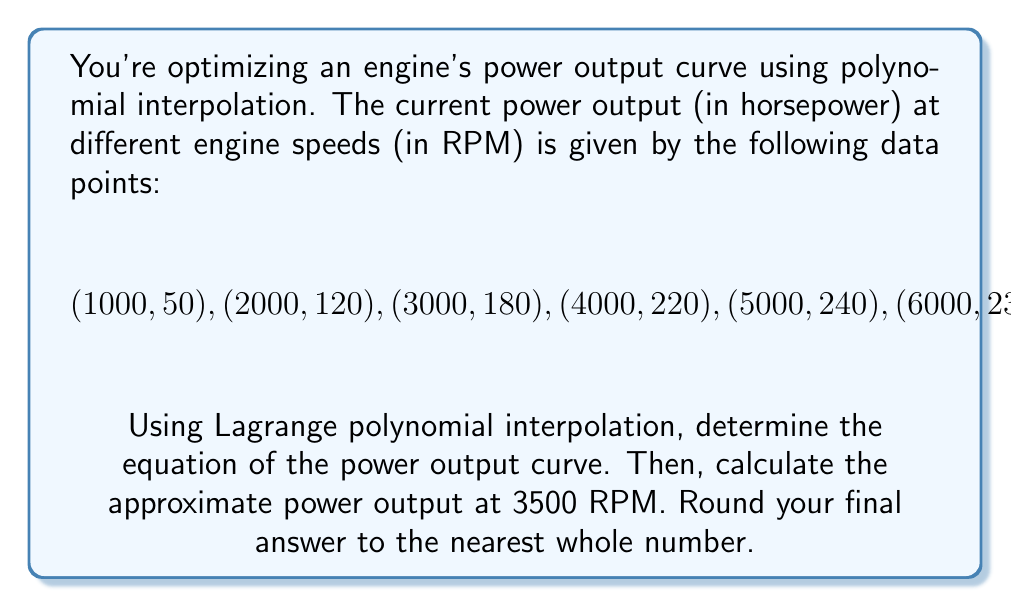Could you help me with this problem? 1) The Lagrange polynomial interpolation formula is:

   $$P(x) = \sum_{i=1}^n y_i \prod_{j \neq i} \frac{x - x_j}{x_i - x_j}$$

2) For our data points, we have:
   $$n = 6$$
   $$(x_1, y_1) = (1000, 50)$$
   $$(x_2, y_2) = (2000, 120)$$
   $$(x_3, y_3) = (3000, 180)$$
   $$(x_4, y_4) = (4000, 220)$$
   $$(x_5, y_5) = (5000, 240)$$
   $$(x_6, y_6) = (6000, 230)$$

3) Substituting these into the Lagrange formula gives us:

   $$P(x) = 50L_1(x) + 120L_2(x) + 180L_3(x) + 220L_4(x) + 240L_5(x) + 230L_6(x)$$

   where each $L_i(x)$ is the Lagrange basis polynomial:

   $$L_i(x) = \prod_{j \neq i} \frac{x - x_j}{x_i - x_j}$$

4) To find the power at 3500 RPM, we need to calculate $P(3500)$:

   $$P(3500) = 50L_1(3500) + 120L_2(3500) + 180L_3(3500) + 220L_4(3500) + 240L_5(3500) + 230L_6(3500)$$

5) Calculating each $L_i(3500)$:

   $$L_1(3500) = \frac{(3500-2000)(3500-3000)(3500-4000)(3500-5000)(3500-6000)}{(1000-2000)(1000-3000)(1000-4000)(1000-5000)(1000-6000)} = -0.0052$$

   $$L_2(3500) = \frac{(3500-1000)(3500-3000)(3500-4000)(3500-5000)(3500-6000)}{(2000-1000)(2000-3000)(2000-4000)(2000-5000)(2000-6000)} = 0.0469$$

   $$L_3(3500) = \frac{(3500-1000)(3500-2000)(3500-4000)(3500-5000)(3500-6000)}{(3000-1000)(3000-2000)(3000-4000)(3000-5000)(3000-6000)} = 0.4688$$

   $$L_4(3500) = \frac{(3500-1000)(3500-2000)(3500-3000)(3500-5000)(3500-6000)}{(4000-1000)(4000-2000)(4000-3000)(4000-5000)(4000-6000)} = 0.4688$$

   $$L_5(3500) = \frac{(3500-1000)(3500-2000)(3500-3000)(3500-4000)(3500-6000)}{(5000-1000)(5000-2000)(5000-3000)(5000-4000)(5000-6000)} = 0.0469$$

   $$L_6(3500) = \frac{(3500-1000)(3500-2000)(3500-3000)(3500-4000)(3500-5000)}{(6000-1000)(6000-2000)(6000-3000)(6000-4000)(6000-5000)} = -0.0052$$

6) Substituting these values:

   $$P(3500) = 50(-0.0052) + 120(0.0469) + 180(0.4688) + 220(0.4688) + 240(0.0469) + 230(-0.0052)$$

7) Calculating:

   $$P(3500) = -0.26 + 5.628 + 84.384 + 103.136 + 11.256 - 1.196 = 202.946$$

8) Rounding to the nearest whole number:

   $$P(3500) \approx 203$$
Answer: 203 horsepower 